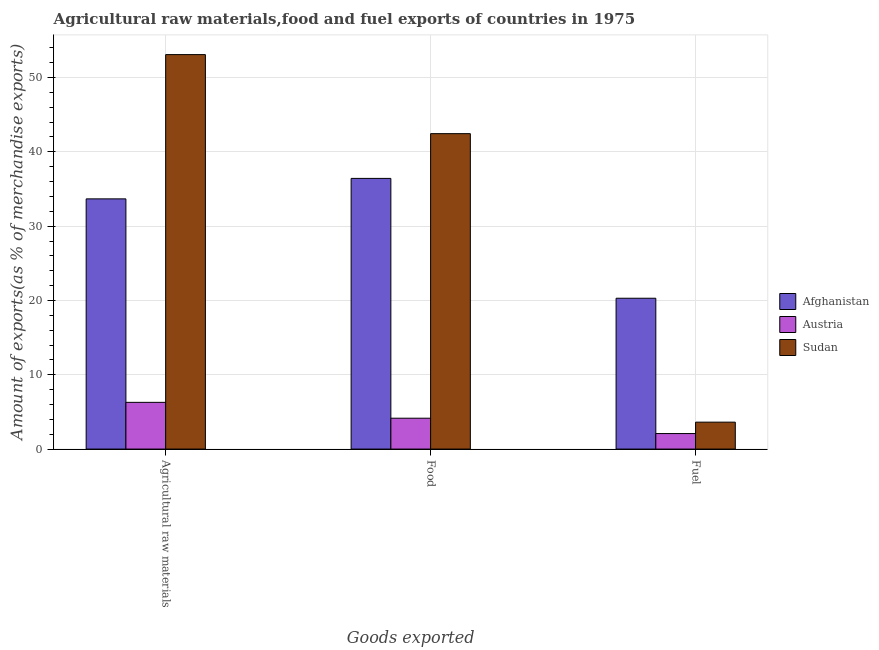How many different coloured bars are there?
Your answer should be compact. 3. Are the number of bars on each tick of the X-axis equal?
Offer a terse response. Yes. How many bars are there on the 2nd tick from the left?
Your answer should be very brief. 3. What is the label of the 1st group of bars from the left?
Make the answer very short. Agricultural raw materials. What is the percentage of food exports in Afghanistan?
Your answer should be compact. 36.43. Across all countries, what is the maximum percentage of food exports?
Offer a very short reply. 42.45. Across all countries, what is the minimum percentage of raw materials exports?
Your answer should be compact. 6.29. In which country was the percentage of fuel exports maximum?
Your answer should be very brief. Afghanistan. What is the total percentage of raw materials exports in the graph?
Provide a succinct answer. 93.05. What is the difference between the percentage of fuel exports in Afghanistan and that in Sudan?
Provide a succinct answer. 16.68. What is the difference between the percentage of raw materials exports in Sudan and the percentage of food exports in Austria?
Provide a short and direct response. 48.93. What is the average percentage of fuel exports per country?
Your answer should be compact. 8.67. What is the difference between the percentage of food exports and percentage of raw materials exports in Austria?
Keep it short and to the point. -2.13. What is the ratio of the percentage of fuel exports in Austria to that in Sudan?
Your answer should be compact. 0.58. Is the difference between the percentage of food exports in Austria and Sudan greater than the difference between the percentage of raw materials exports in Austria and Sudan?
Keep it short and to the point. Yes. What is the difference between the highest and the second highest percentage of raw materials exports?
Keep it short and to the point. 19.42. What is the difference between the highest and the lowest percentage of fuel exports?
Provide a succinct answer. 18.21. In how many countries, is the percentage of fuel exports greater than the average percentage of fuel exports taken over all countries?
Make the answer very short. 1. Is the sum of the percentage of food exports in Austria and Sudan greater than the maximum percentage of raw materials exports across all countries?
Your answer should be very brief. No. What does the 3rd bar from the left in Agricultural raw materials represents?
Ensure brevity in your answer.  Sudan. What does the 1st bar from the right in Agricultural raw materials represents?
Your response must be concise. Sudan. How many bars are there?
Make the answer very short. 9. How many countries are there in the graph?
Your answer should be very brief. 3. What is the difference between two consecutive major ticks on the Y-axis?
Give a very brief answer. 10. Does the graph contain any zero values?
Your answer should be very brief. No. Does the graph contain grids?
Your answer should be very brief. Yes. Where does the legend appear in the graph?
Your answer should be compact. Center right. How many legend labels are there?
Your answer should be compact. 3. What is the title of the graph?
Provide a succinct answer. Agricultural raw materials,food and fuel exports of countries in 1975. What is the label or title of the X-axis?
Your answer should be very brief. Goods exported. What is the label or title of the Y-axis?
Offer a very short reply. Amount of exports(as % of merchandise exports). What is the Amount of exports(as % of merchandise exports) of Afghanistan in Agricultural raw materials?
Offer a terse response. 33.67. What is the Amount of exports(as % of merchandise exports) in Austria in Agricultural raw materials?
Keep it short and to the point. 6.29. What is the Amount of exports(as % of merchandise exports) of Sudan in Agricultural raw materials?
Offer a terse response. 53.09. What is the Amount of exports(as % of merchandise exports) in Afghanistan in Food?
Make the answer very short. 36.43. What is the Amount of exports(as % of merchandise exports) of Austria in Food?
Your answer should be very brief. 4.15. What is the Amount of exports(as % of merchandise exports) of Sudan in Food?
Your answer should be compact. 42.45. What is the Amount of exports(as % of merchandise exports) in Afghanistan in Fuel?
Provide a short and direct response. 20.3. What is the Amount of exports(as % of merchandise exports) of Austria in Fuel?
Give a very brief answer. 2.09. What is the Amount of exports(as % of merchandise exports) in Sudan in Fuel?
Offer a very short reply. 3.62. Across all Goods exported, what is the maximum Amount of exports(as % of merchandise exports) of Afghanistan?
Provide a succinct answer. 36.43. Across all Goods exported, what is the maximum Amount of exports(as % of merchandise exports) of Austria?
Keep it short and to the point. 6.29. Across all Goods exported, what is the maximum Amount of exports(as % of merchandise exports) in Sudan?
Give a very brief answer. 53.09. Across all Goods exported, what is the minimum Amount of exports(as % of merchandise exports) of Afghanistan?
Keep it short and to the point. 20.3. Across all Goods exported, what is the minimum Amount of exports(as % of merchandise exports) in Austria?
Ensure brevity in your answer.  2.09. Across all Goods exported, what is the minimum Amount of exports(as % of merchandise exports) in Sudan?
Offer a terse response. 3.62. What is the total Amount of exports(as % of merchandise exports) in Afghanistan in the graph?
Your answer should be very brief. 90.4. What is the total Amount of exports(as % of merchandise exports) in Austria in the graph?
Your answer should be compact. 12.53. What is the total Amount of exports(as % of merchandise exports) in Sudan in the graph?
Provide a short and direct response. 99.16. What is the difference between the Amount of exports(as % of merchandise exports) of Afghanistan in Agricultural raw materials and that in Food?
Your answer should be compact. -2.76. What is the difference between the Amount of exports(as % of merchandise exports) of Austria in Agricultural raw materials and that in Food?
Keep it short and to the point. 2.13. What is the difference between the Amount of exports(as % of merchandise exports) in Sudan in Agricultural raw materials and that in Food?
Provide a succinct answer. 10.64. What is the difference between the Amount of exports(as % of merchandise exports) in Afghanistan in Agricultural raw materials and that in Fuel?
Your answer should be compact. 13.37. What is the difference between the Amount of exports(as % of merchandise exports) of Austria in Agricultural raw materials and that in Fuel?
Make the answer very short. 4.2. What is the difference between the Amount of exports(as % of merchandise exports) in Sudan in Agricultural raw materials and that in Fuel?
Provide a short and direct response. 49.47. What is the difference between the Amount of exports(as % of merchandise exports) in Afghanistan in Food and that in Fuel?
Provide a short and direct response. 16.13. What is the difference between the Amount of exports(as % of merchandise exports) of Austria in Food and that in Fuel?
Keep it short and to the point. 2.07. What is the difference between the Amount of exports(as % of merchandise exports) of Sudan in Food and that in Fuel?
Give a very brief answer. 38.83. What is the difference between the Amount of exports(as % of merchandise exports) of Afghanistan in Agricultural raw materials and the Amount of exports(as % of merchandise exports) of Austria in Food?
Your answer should be very brief. 29.52. What is the difference between the Amount of exports(as % of merchandise exports) of Afghanistan in Agricultural raw materials and the Amount of exports(as % of merchandise exports) of Sudan in Food?
Your response must be concise. -8.78. What is the difference between the Amount of exports(as % of merchandise exports) in Austria in Agricultural raw materials and the Amount of exports(as % of merchandise exports) in Sudan in Food?
Provide a succinct answer. -36.16. What is the difference between the Amount of exports(as % of merchandise exports) of Afghanistan in Agricultural raw materials and the Amount of exports(as % of merchandise exports) of Austria in Fuel?
Keep it short and to the point. 31.58. What is the difference between the Amount of exports(as % of merchandise exports) in Afghanistan in Agricultural raw materials and the Amount of exports(as % of merchandise exports) in Sudan in Fuel?
Offer a terse response. 30.05. What is the difference between the Amount of exports(as % of merchandise exports) of Austria in Agricultural raw materials and the Amount of exports(as % of merchandise exports) of Sudan in Fuel?
Provide a short and direct response. 2.66. What is the difference between the Amount of exports(as % of merchandise exports) in Afghanistan in Food and the Amount of exports(as % of merchandise exports) in Austria in Fuel?
Your response must be concise. 34.34. What is the difference between the Amount of exports(as % of merchandise exports) in Afghanistan in Food and the Amount of exports(as % of merchandise exports) in Sudan in Fuel?
Ensure brevity in your answer.  32.81. What is the difference between the Amount of exports(as % of merchandise exports) in Austria in Food and the Amount of exports(as % of merchandise exports) in Sudan in Fuel?
Provide a succinct answer. 0.53. What is the average Amount of exports(as % of merchandise exports) in Afghanistan per Goods exported?
Make the answer very short. 30.13. What is the average Amount of exports(as % of merchandise exports) of Austria per Goods exported?
Your answer should be very brief. 4.18. What is the average Amount of exports(as % of merchandise exports) in Sudan per Goods exported?
Keep it short and to the point. 33.05. What is the difference between the Amount of exports(as % of merchandise exports) in Afghanistan and Amount of exports(as % of merchandise exports) in Austria in Agricultural raw materials?
Keep it short and to the point. 27.38. What is the difference between the Amount of exports(as % of merchandise exports) in Afghanistan and Amount of exports(as % of merchandise exports) in Sudan in Agricultural raw materials?
Your answer should be very brief. -19.42. What is the difference between the Amount of exports(as % of merchandise exports) in Austria and Amount of exports(as % of merchandise exports) in Sudan in Agricultural raw materials?
Provide a succinct answer. -46.8. What is the difference between the Amount of exports(as % of merchandise exports) in Afghanistan and Amount of exports(as % of merchandise exports) in Austria in Food?
Provide a short and direct response. 32.27. What is the difference between the Amount of exports(as % of merchandise exports) of Afghanistan and Amount of exports(as % of merchandise exports) of Sudan in Food?
Your response must be concise. -6.02. What is the difference between the Amount of exports(as % of merchandise exports) in Austria and Amount of exports(as % of merchandise exports) in Sudan in Food?
Make the answer very short. -38.29. What is the difference between the Amount of exports(as % of merchandise exports) of Afghanistan and Amount of exports(as % of merchandise exports) of Austria in Fuel?
Make the answer very short. 18.21. What is the difference between the Amount of exports(as % of merchandise exports) in Afghanistan and Amount of exports(as % of merchandise exports) in Sudan in Fuel?
Provide a short and direct response. 16.68. What is the difference between the Amount of exports(as % of merchandise exports) of Austria and Amount of exports(as % of merchandise exports) of Sudan in Fuel?
Your answer should be compact. -1.53. What is the ratio of the Amount of exports(as % of merchandise exports) in Afghanistan in Agricultural raw materials to that in Food?
Provide a succinct answer. 0.92. What is the ratio of the Amount of exports(as % of merchandise exports) in Austria in Agricultural raw materials to that in Food?
Your response must be concise. 1.51. What is the ratio of the Amount of exports(as % of merchandise exports) in Sudan in Agricultural raw materials to that in Food?
Your response must be concise. 1.25. What is the ratio of the Amount of exports(as % of merchandise exports) of Afghanistan in Agricultural raw materials to that in Fuel?
Your response must be concise. 1.66. What is the ratio of the Amount of exports(as % of merchandise exports) in Austria in Agricultural raw materials to that in Fuel?
Give a very brief answer. 3.01. What is the ratio of the Amount of exports(as % of merchandise exports) in Sudan in Agricultural raw materials to that in Fuel?
Make the answer very short. 14.65. What is the ratio of the Amount of exports(as % of merchandise exports) in Afghanistan in Food to that in Fuel?
Keep it short and to the point. 1.79. What is the ratio of the Amount of exports(as % of merchandise exports) of Austria in Food to that in Fuel?
Provide a short and direct response. 1.99. What is the ratio of the Amount of exports(as % of merchandise exports) in Sudan in Food to that in Fuel?
Make the answer very short. 11.72. What is the difference between the highest and the second highest Amount of exports(as % of merchandise exports) in Afghanistan?
Keep it short and to the point. 2.76. What is the difference between the highest and the second highest Amount of exports(as % of merchandise exports) of Austria?
Provide a succinct answer. 2.13. What is the difference between the highest and the second highest Amount of exports(as % of merchandise exports) of Sudan?
Your answer should be compact. 10.64. What is the difference between the highest and the lowest Amount of exports(as % of merchandise exports) in Afghanistan?
Ensure brevity in your answer.  16.13. What is the difference between the highest and the lowest Amount of exports(as % of merchandise exports) of Austria?
Your answer should be compact. 4.2. What is the difference between the highest and the lowest Amount of exports(as % of merchandise exports) of Sudan?
Your response must be concise. 49.47. 